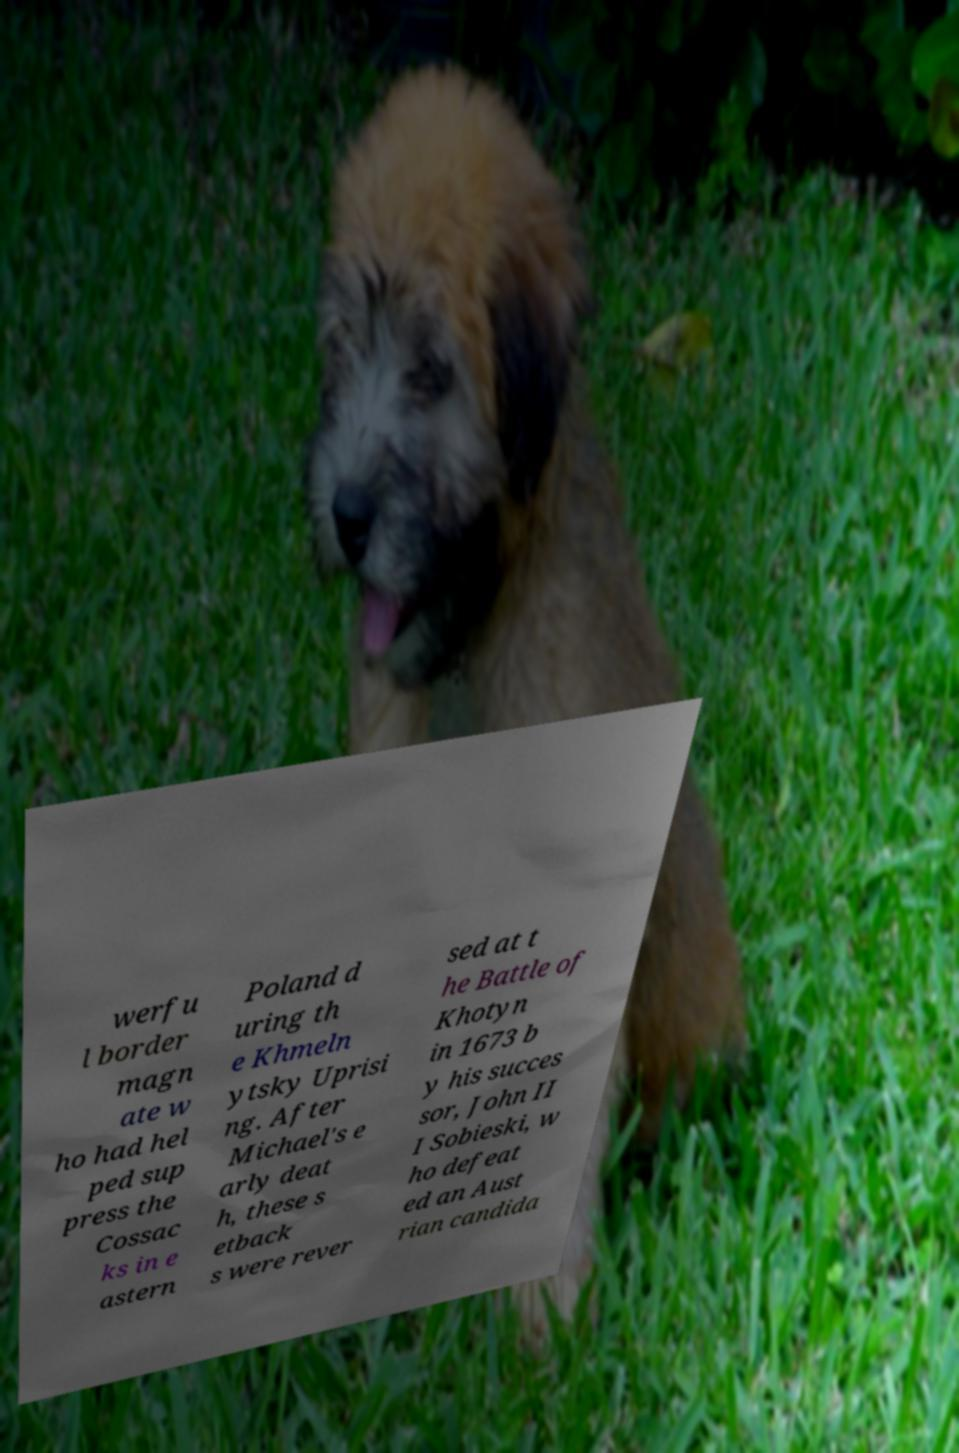Please identify and transcribe the text found in this image. werfu l border magn ate w ho had hel ped sup press the Cossac ks in e astern Poland d uring th e Khmeln ytsky Uprisi ng. After Michael's e arly deat h, these s etback s were rever sed at t he Battle of Khotyn in 1673 b y his succes sor, John II I Sobieski, w ho defeat ed an Aust rian candida 